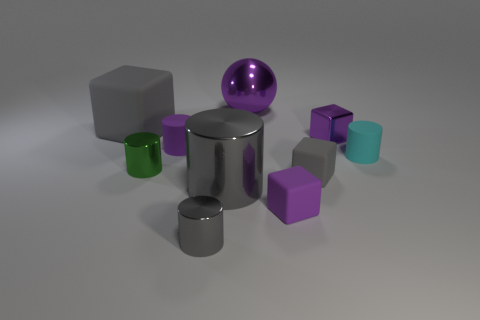Subtract 1 cylinders. How many cylinders are left? 4 Subtract all green cylinders. How many cylinders are left? 4 Subtract all large cylinders. How many cylinders are left? 4 Subtract all blue cylinders. Subtract all green spheres. How many cylinders are left? 5 Subtract all balls. How many objects are left? 9 Subtract all small yellow shiny spheres. Subtract all gray cylinders. How many objects are left? 8 Add 6 rubber cubes. How many rubber cubes are left? 9 Add 7 big shiny spheres. How many big shiny spheres exist? 8 Subtract 0 yellow cylinders. How many objects are left? 10 